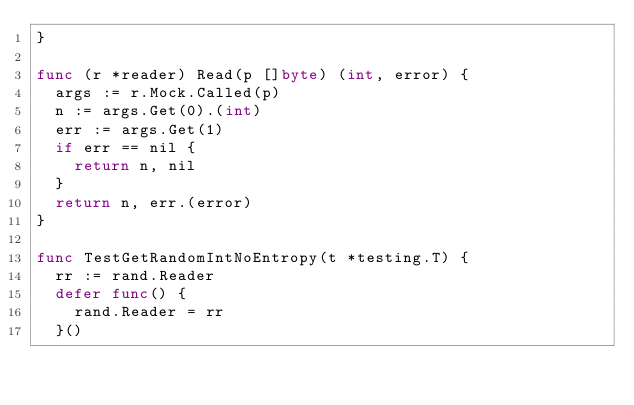<code> <loc_0><loc_0><loc_500><loc_500><_Go_>}

func (r *reader) Read(p []byte) (int, error) {
	args := r.Mock.Called(p)
	n := args.Get(0).(int)
	err := args.Get(1)
	if err == nil {
		return n, nil
	}
	return n, err.(error)
}

func TestGetRandomIntNoEntropy(t *testing.T) {
	rr := rand.Reader
	defer func() {
		rand.Reader = rr
	}()</code> 